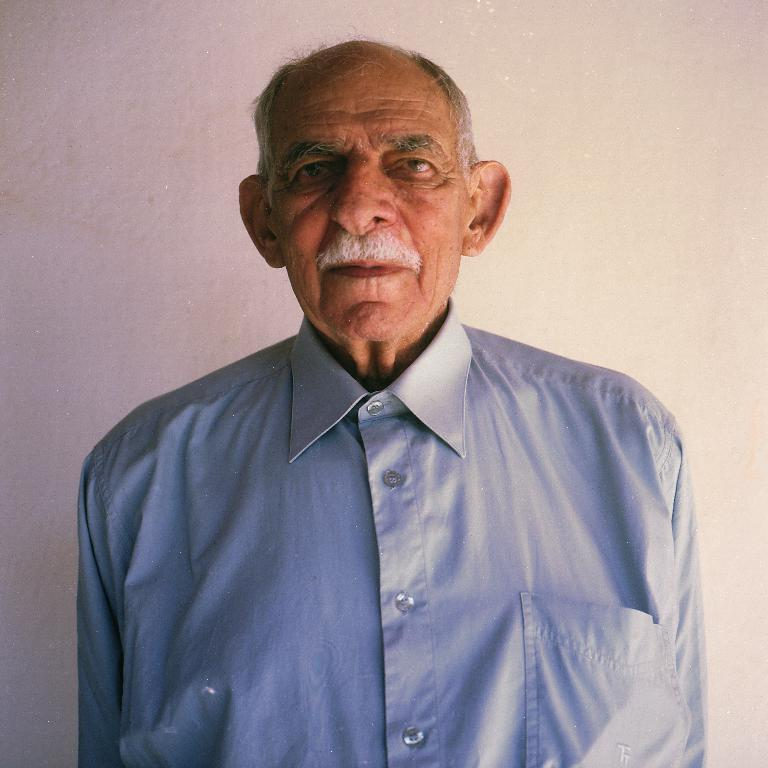Who is the main subject in the image? There is an old man in the center of the image. What is the old man wearing? The old man is wearing a shirt. What can be seen behind the old man in the image? There is a plain wall in the background of the image. What type of pump is being used by the old man in the image? There is no pump present in the image; the old man is simply standing in front of a plain wall. 